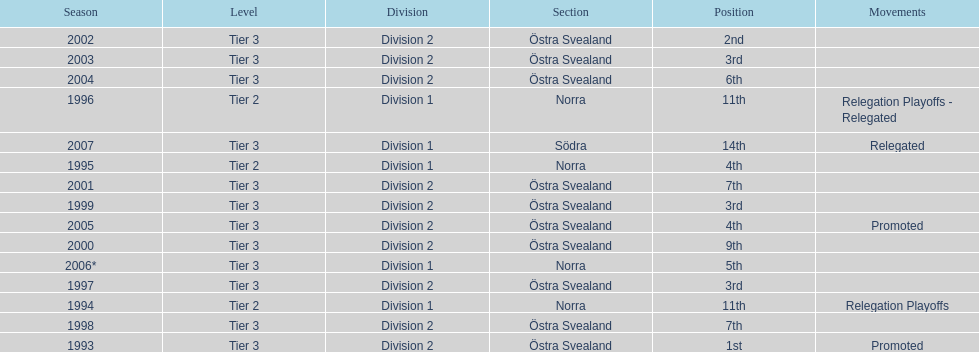In total, how many times were they promoted? 2. 